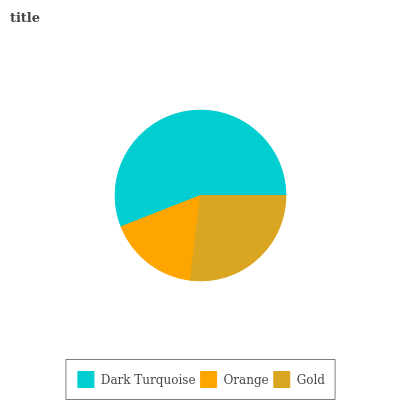Is Orange the minimum?
Answer yes or no. Yes. Is Dark Turquoise the maximum?
Answer yes or no. Yes. Is Gold the minimum?
Answer yes or no. No. Is Gold the maximum?
Answer yes or no. No. Is Gold greater than Orange?
Answer yes or no. Yes. Is Orange less than Gold?
Answer yes or no. Yes. Is Orange greater than Gold?
Answer yes or no. No. Is Gold less than Orange?
Answer yes or no. No. Is Gold the high median?
Answer yes or no. Yes. Is Gold the low median?
Answer yes or no. Yes. Is Orange the high median?
Answer yes or no. No. Is Dark Turquoise the low median?
Answer yes or no. No. 